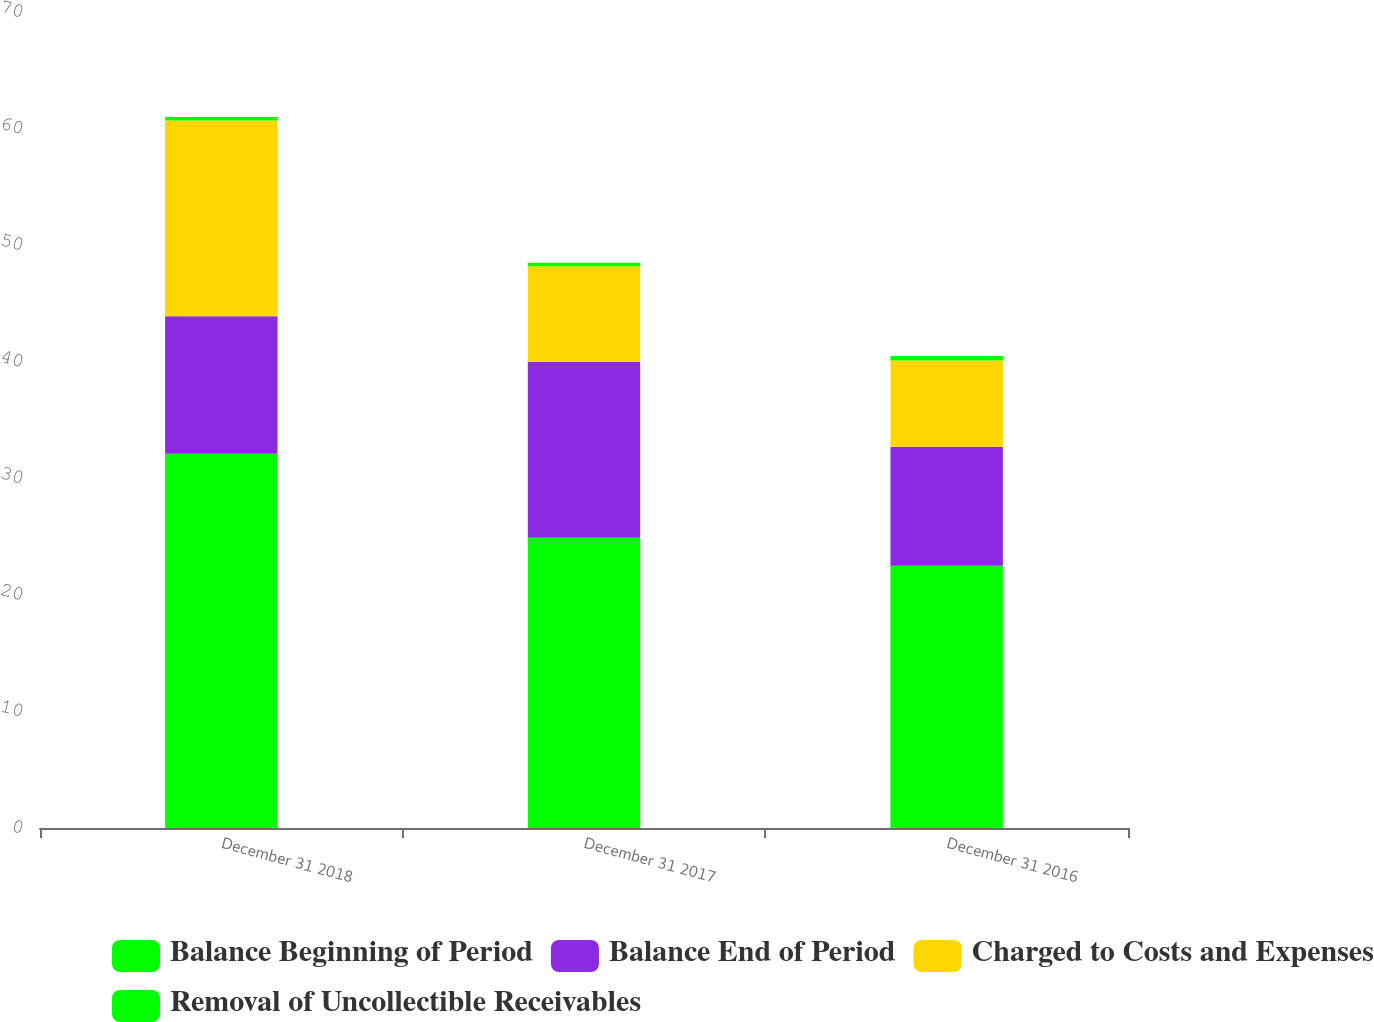Convert chart to OTSL. <chart><loc_0><loc_0><loc_500><loc_500><stacked_bar_chart><ecel><fcel>December 31 2018<fcel>December 31 2017<fcel>December 31 2016<nl><fcel>Balance Beginning of Period<fcel>32.1<fcel>24.9<fcel>22.5<nl><fcel>Balance End of Period<fcel>11.8<fcel>15.1<fcel>10.2<nl><fcel>Charged to Costs and Expenses<fcel>16.8<fcel>8.2<fcel>7.4<nl><fcel>Removal of Uncollectible Receivables<fcel>0.3<fcel>0.3<fcel>0.4<nl></chart> 